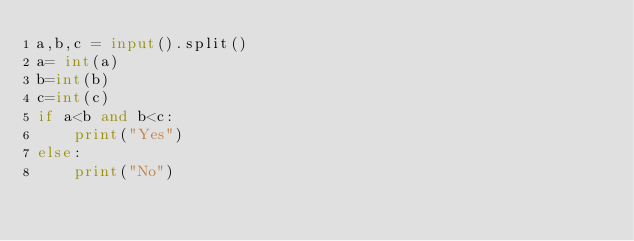<code> <loc_0><loc_0><loc_500><loc_500><_Python_>a,b,c = input().split()
a= int(a)
b=int(b)
c=int(c)
if a<b and b<c:
    print("Yes")
else:
    print("No")
</code> 